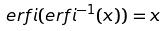Convert formula to latex. <formula><loc_0><loc_0><loc_500><loc_500>e r f i ( e r f i ^ { - 1 } ( x ) ) = x</formula> 